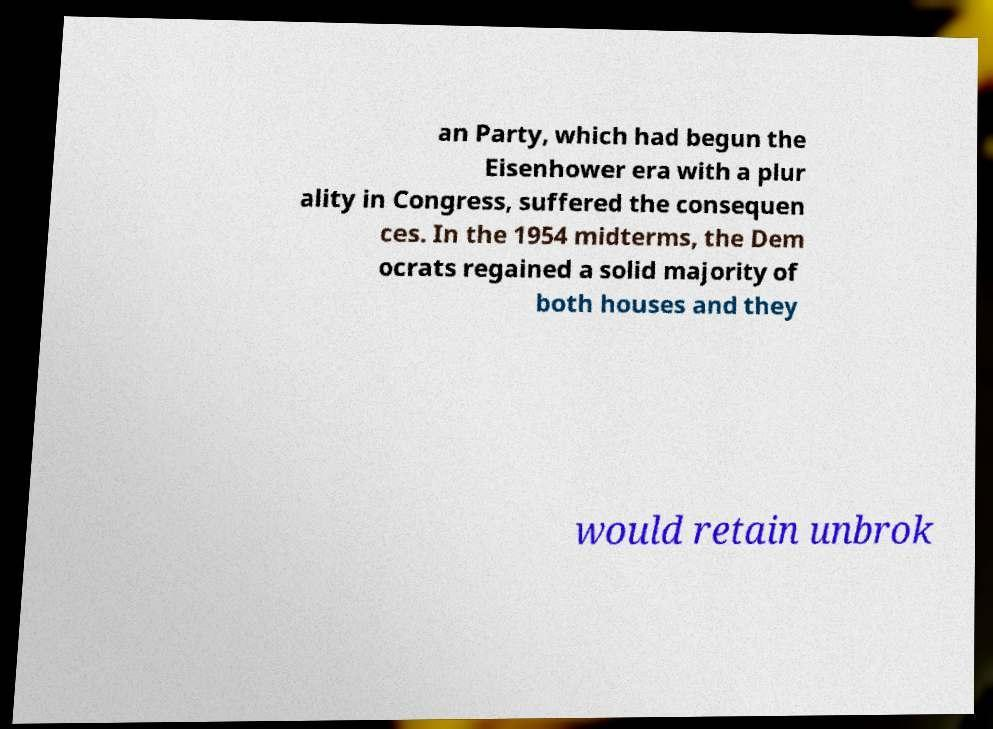I need the written content from this picture converted into text. Can you do that? an Party, which had begun the Eisenhower era with a plur ality in Congress, suffered the consequen ces. In the 1954 midterms, the Dem ocrats regained a solid majority of both houses and they would retain unbrok 